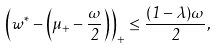<formula> <loc_0><loc_0><loc_500><loc_500>\left ( w ^ { * } - \left ( \mu _ { + } - \frac { \omega } { 2 } \right ) \right ) _ { + } \leq \frac { ( 1 - \lambda ) \omega } { 2 } ,</formula> 